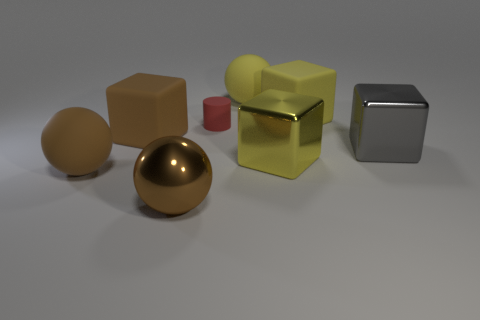Subtract all blue blocks. Subtract all brown spheres. How many blocks are left? 4 Add 1 purple objects. How many objects exist? 9 Subtract all balls. How many objects are left? 5 Add 8 small cylinders. How many small cylinders are left? 9 Add 4 red matte objects. How many red matte objects exist? 5 Subtract 0 blue spheres. How many objects are left? 8 Subtract all tiny green metal things. Subtract all big brown metallic things. How many objects are left? 7 